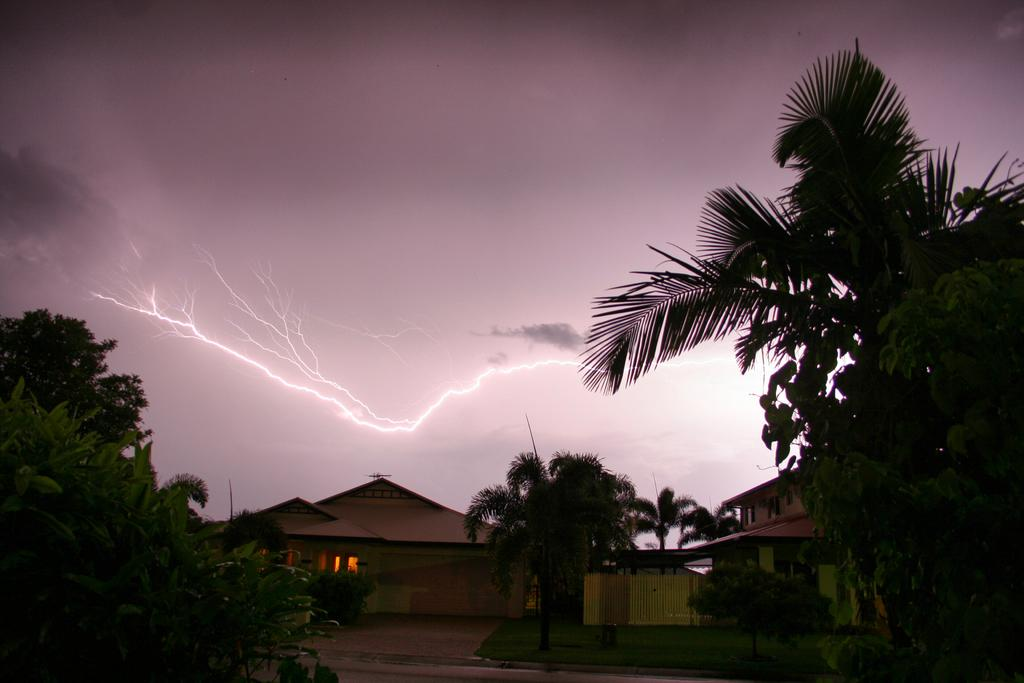What can be seen in the foreground of the image? There are trees and houses in the foreground of the image. What is the weather like in the image? There is thunder in the sky, indicating a stormy or cloudy weather. What type of produce is being harvested in the image? There is no produce or harvesting activity visible in the image; it features trees and houses with thunder in the sky. Can you see any wings on the trees in the image? There are no wings present on the trees in the image; they are regular trees with leaves and branches. 